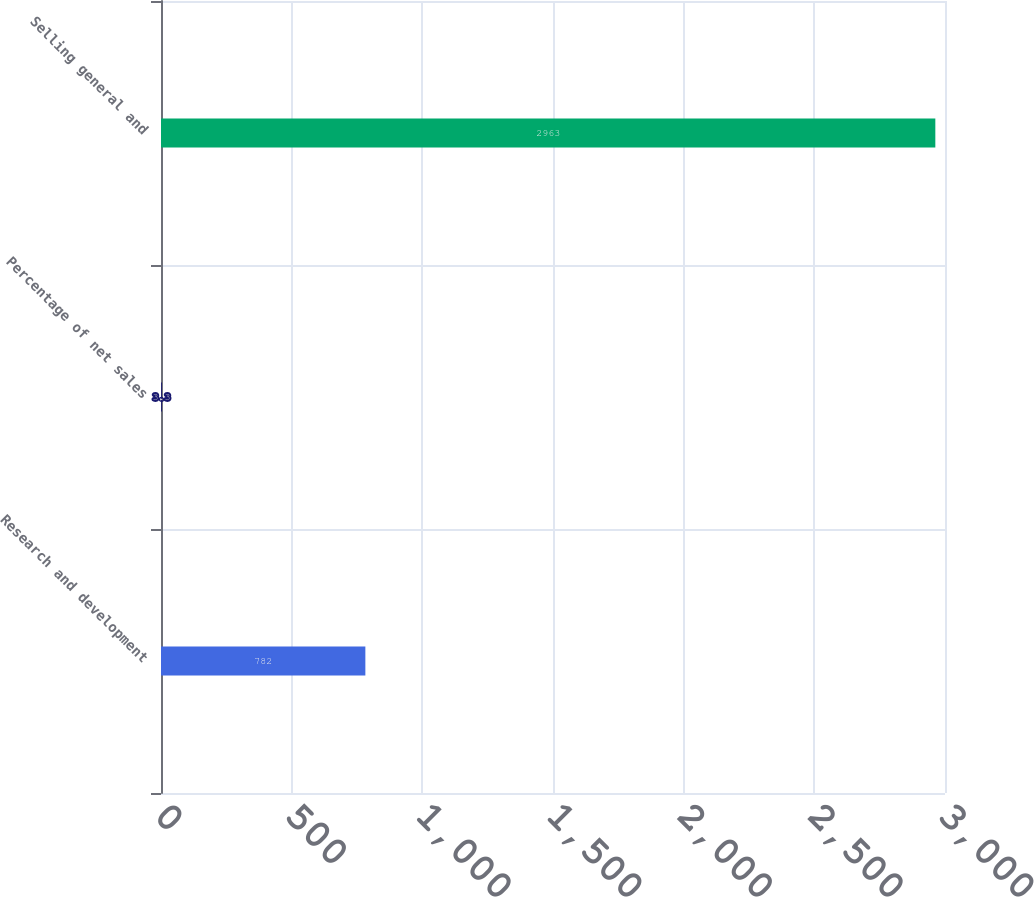<chart> <loc_0><loc_0><loc_500><loc_500><bar_chart><fcel>Research and development<fcel>Percentage of net sales<fcel>Selling general and<nl><fcel>782<fcel>3.3<fcel>2963<nl></chart> 